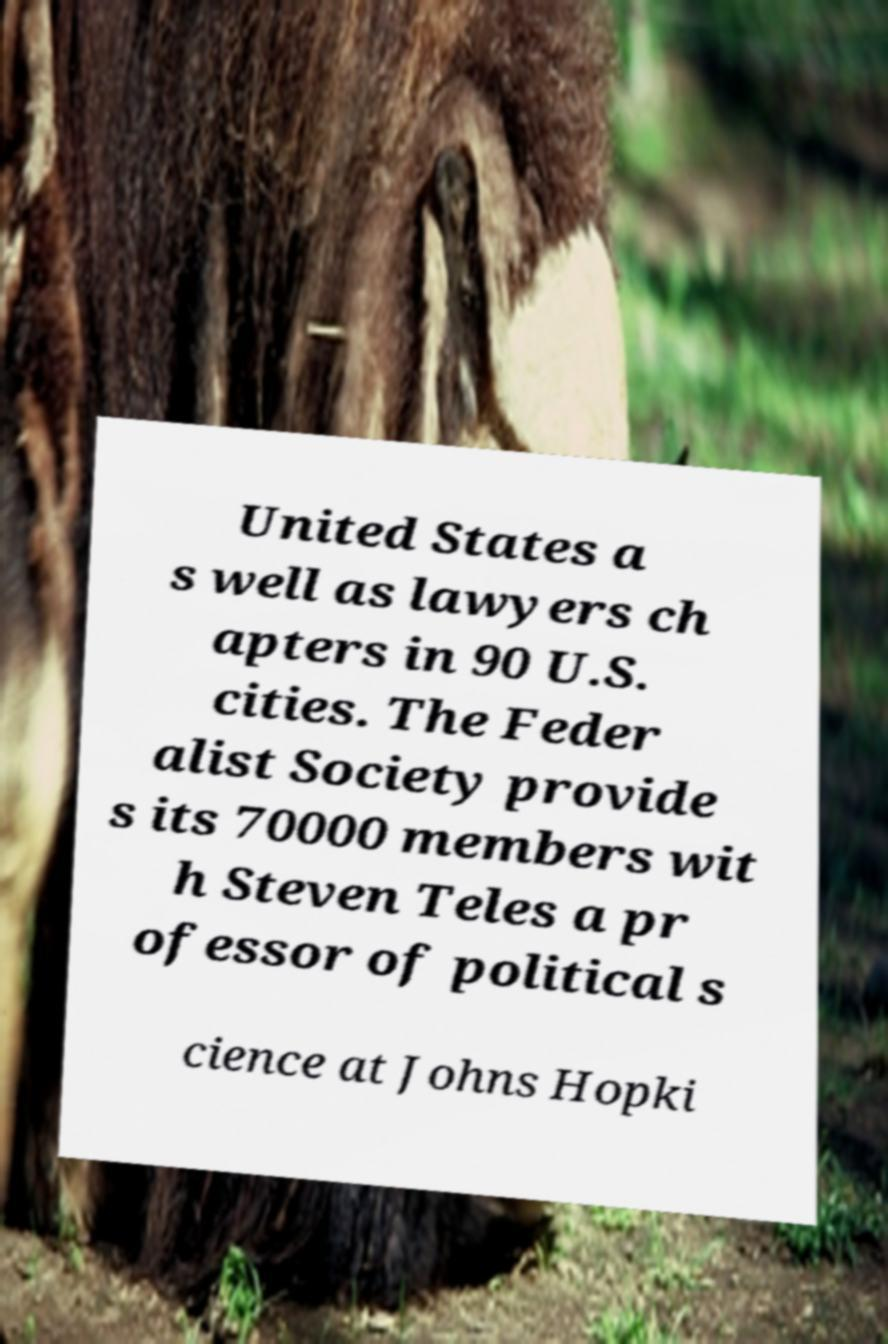Please identify and transcribe the text found in this image. United States a s well as lawyers ch apters in 90 U.S. cities. The Feder alist Society provide s its 70000 members wit h Steven Teles a pr ofessor of political s cience at Johns Hopki 